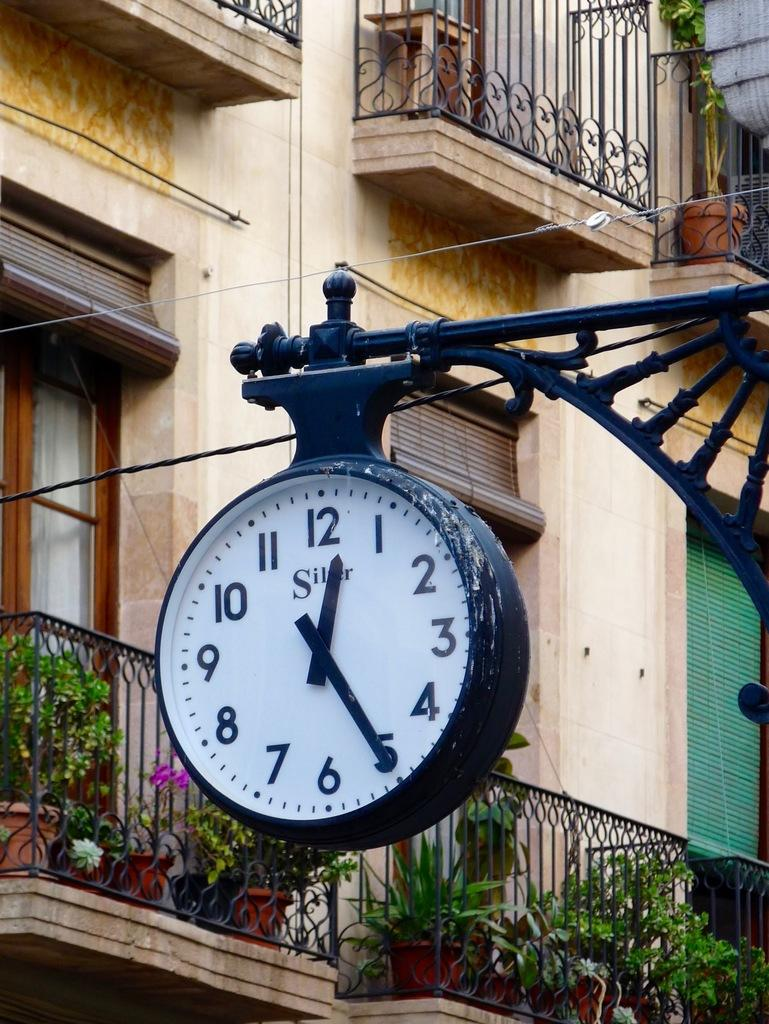<image>
Relay a brief, clear account of the picture shown. An old Silver brand clock hanging from an arm of a street lamp post. 